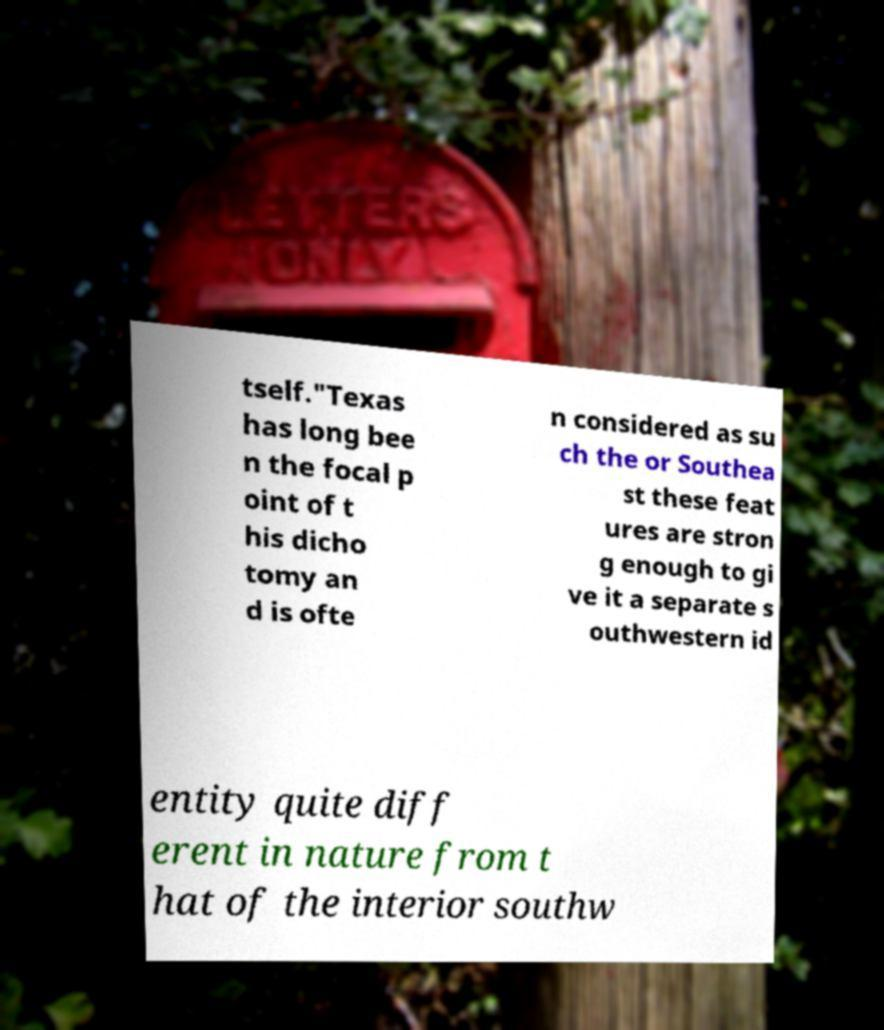There's text embedded in this image that I need extracted. Can you transcribe it verbatim? tself."Texas has long bee n the focal p oint of t his dicho tomy an d is ofte n considered as su ch the or Southea st these feat ures are stron g enough to gi ve it a separate s outhwestern id entity quite diff erent in nature from t hat of the interior southw 